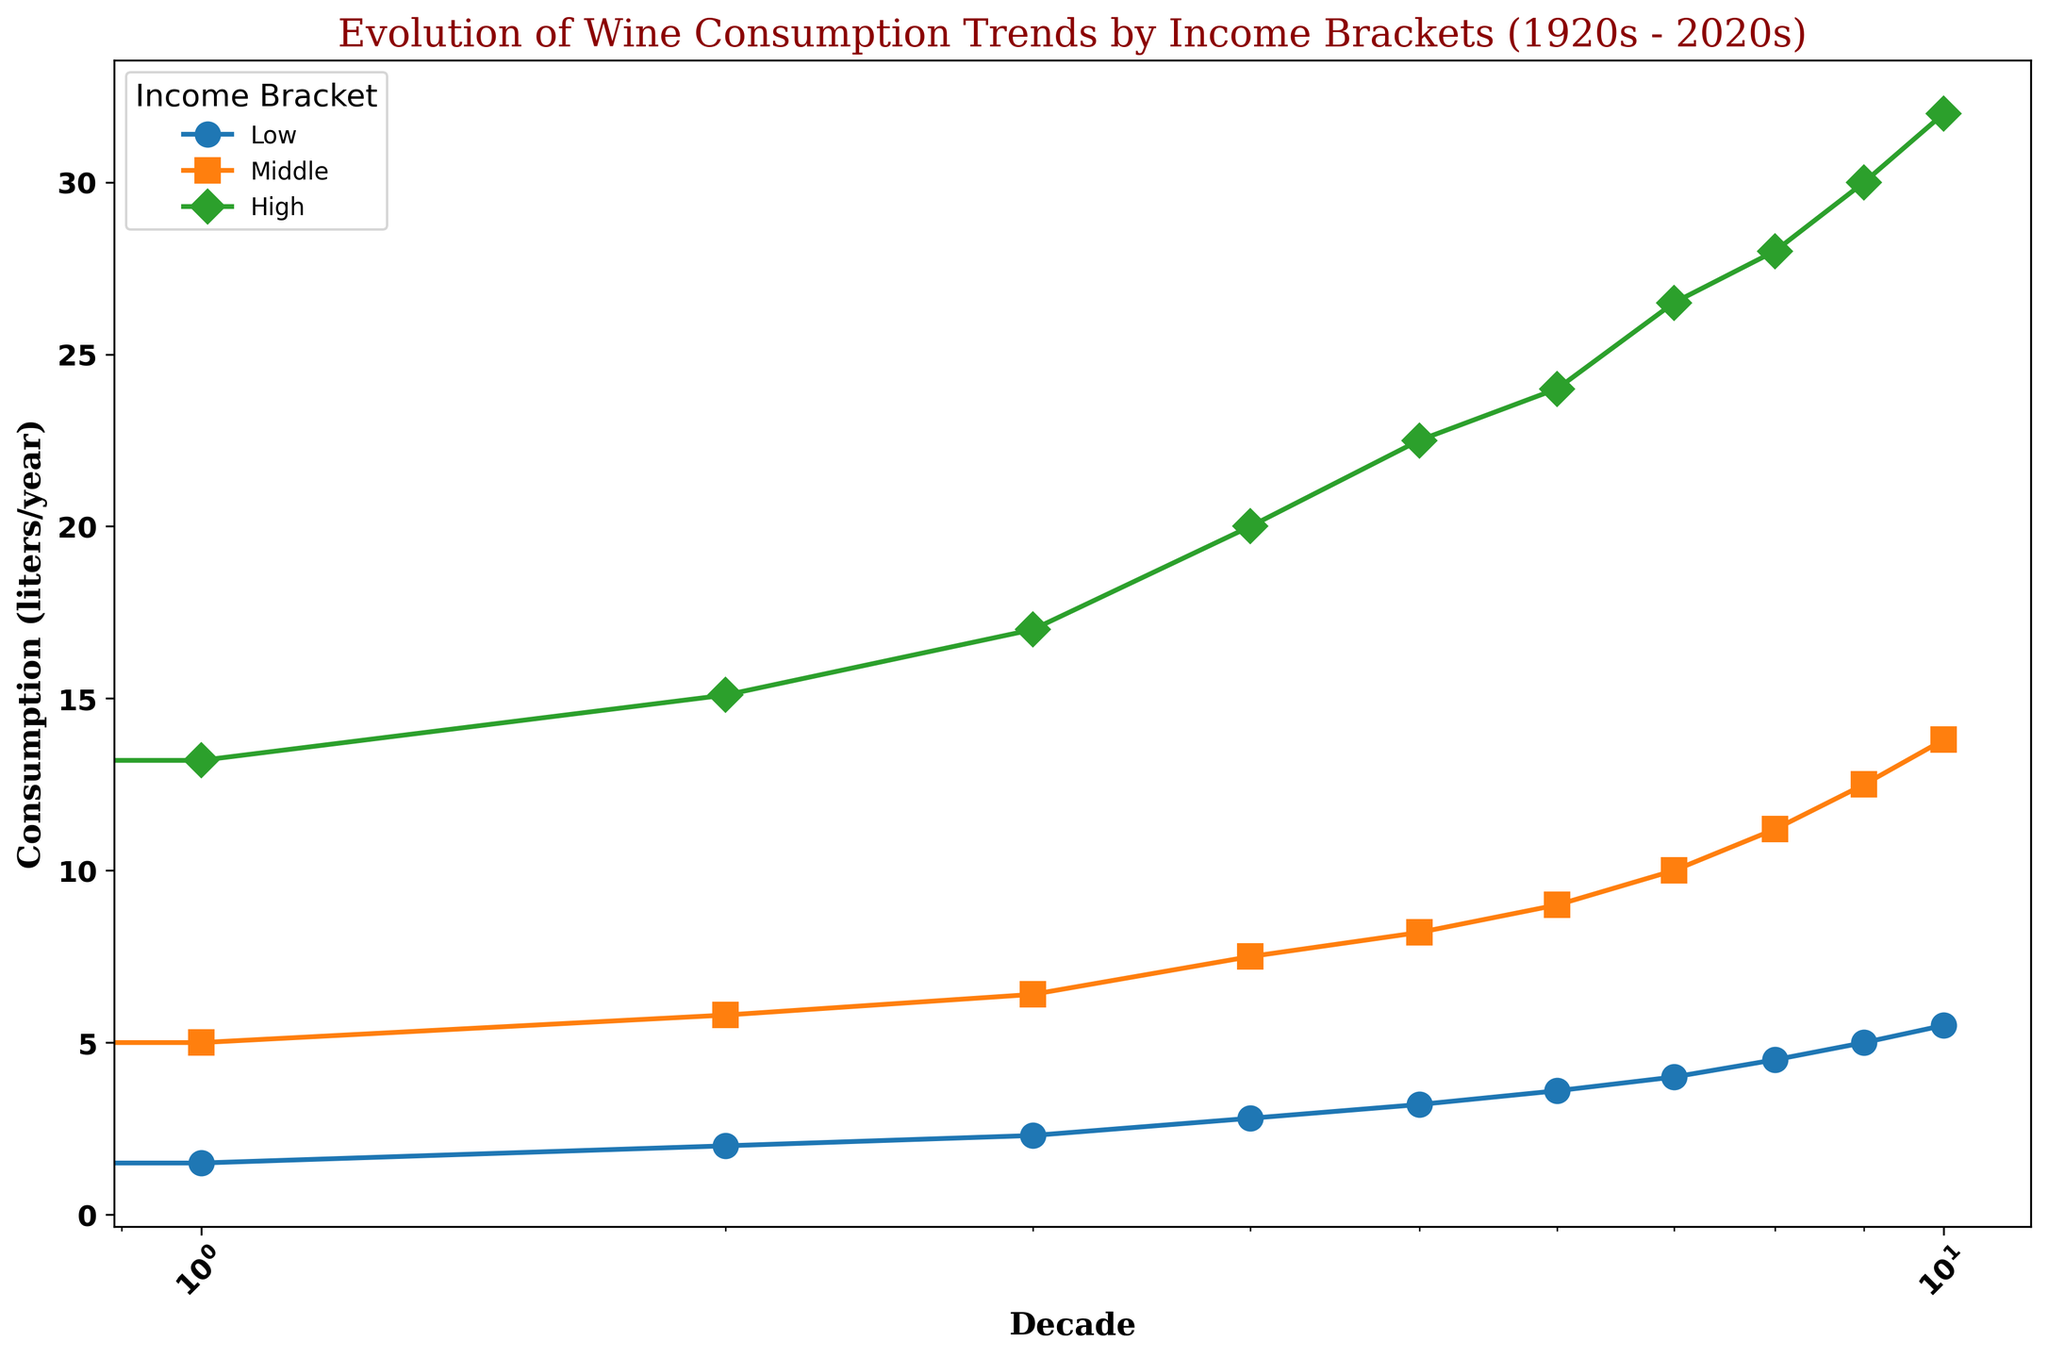What is the overall trend in wine consumption for the high-income bracket from 1920s to 2020s? The plot shows a steady increase in wine consumption for the high-income bracket from 12.5 liters/year in the 1920s to 32.0 liters/year in the 2020s.
Answer: Steady increase Which income bracket has the most significant change in wine consumption over the past century? By visually comparing the slopes of the lines, the high-income bracket shows the steepest increase from 12.5 liters/year in the 1920s to 32.0 liters/year in the 2020s, indicating the most significant change.
Answer: High-income What is the difference in wine consumption between the middle and low-income brackets in the 2020s? In the 2020s, the consumption for the middle-income bracket is 13.8 liters/year, and for the low-income bracket, it is 5.5 liters/year. The difference is 13.8 - 5.5 = 8.3 liters/year.
Answer: 8.3 liters/year How does the wine consumption in the 1940s for the low-income bracket compare to the middle-income bracket? In the 1940s, the low-income bracket consumed 2.0 liters/year, while the middle-income bracket consumed 5.8 liters/year. The middle-income bracket consumed more wine.
Answer: Low: 2.0, Middle: 5.8 By how much did the wine consumption in the high-income bracket grow from the 1950s to the 2020s? In the 1950s, the high-income bracket consumption was 17.0 liters/year, and in the 2020s, it was 32.0 liters/year. The growth is 32.0 - 17.0 = 15.0 liters/year.
Answer: 15.0 liters/year What is the average wine consumption for the middle-income bracket across all decades? The consumption for the middle-income bracket by decade: 4.3, 5.0, 5.8, 6.4, 7.5, 8.2, 9.0, 10.0, 11.2, 12.5, 13.8. The sum is 94.7, and the average is 94.7 / 11 ≈ 8.6 liters/year.
Answer: 8.6 liters/year Which decade saw the highest increase in wine consumption for the low-income bracket? By checking the values decade by decade, the increase from the 1940s (2.0) to the 1950s (2.3) is 0.3, the smallest. The largest increase was between the 2010s (5.0) and 2020s (5.5), amounting to 0.5 liters/year.
Answer: 2020s Is there any decade where wine consumption for the high-income bracket decreased? The plotted line for the high-income bracket consistently shows an upward trend without any dips, indicating no decade with decreased consumption.
Answer: No What is the visual difference between the trend lines for the low and high-income brackets? The high-income bracket's trend line is steeper and higher overall, showing a greater increase in consumption, while the low-income bracket's trend line is more gradual and lower, indicating smaller increases.
Answer: Steeper and higher vs. gradual and lower 